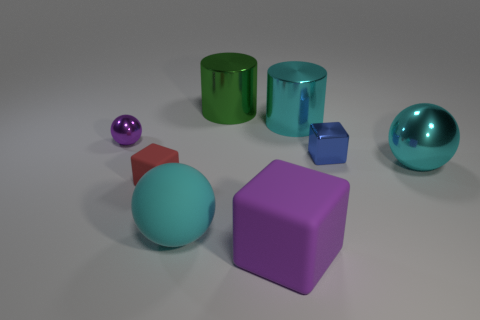Are there the same number of cyan balls that are behind the tiny purple metallic ball and large cylinders left of the large purple rubber block?
Provide a short and direct response. No. How many other objects are the same color as the tiny matte thing?
Your answer should be compact. 0. Is the color of the small matte block the same as the metal ball that is in front of the tiny blue object?
Make the answer very short. No. What number of cyan things are objects or big things?
Provide a succinct answer. 3. Are there the same number of large cyan shiny cylinders that are to the left of the tiny purple thing and green metallic objects?
Offer a very short reply. No. Is there any other thing that is the same size as the metallic block?
Your response must be concise. Yes. There is a small object that is the same shape as the big cyan rubber thing; what is its color?
Offer a very short reply. Purple. What number of large purple shiny things have the same shape as the small rubber object?
Make the answer very short. 0. There is another big ball that is the same color as the large shiny ball; what is it made of?
Give a very brief answer. Rubber. What number of purple metallic balls are there?
Your answer should be compact. 1. 